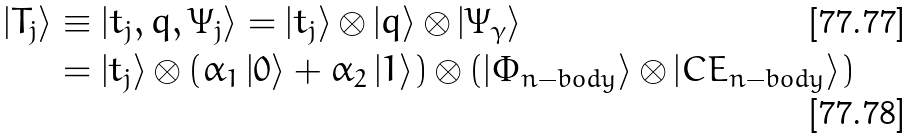<formula> <loc_0><loc_0><loc_500><loc_500>\left | T _ { j } \right \rangle & \equiv \left | t _ { j } , q , \Psi _ { j } \right \rangle = \left | t _ { j } \right \rangle { \otimes } \left | q \right \rangle { \otimes } \left | \Psi _ { \gamma } \right \rangle \\ & = \left | t _ { j } \right \rangle { \otimes } \left ( \alpha _ { 1 } \left | 0 \right \rangle + \alpha _ { 2 } \left | 1 \right \rangle \right ) { \otimes } \left ( \left | \Phi _ { n - b o d y } \right \rangle { \otimes } \left | C E _ { n - b o d y } \right \rangle \right )</formula> 